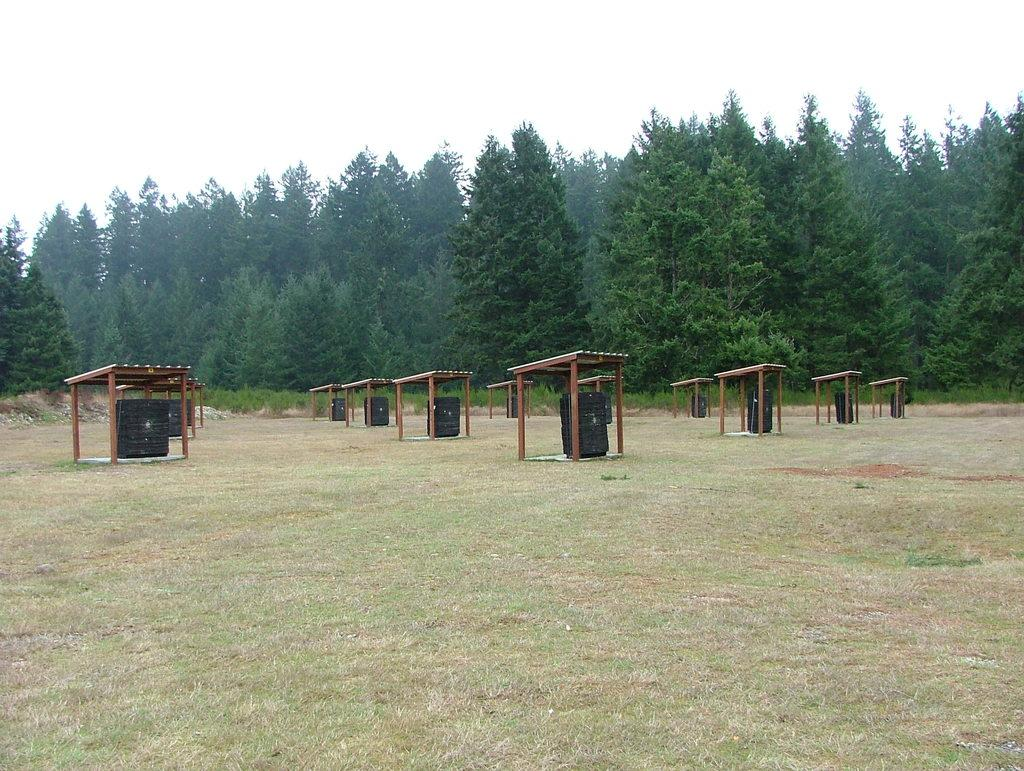What type of ground is visible in the image? There is a ground visible in the image. What structures are present on the ground? There are small sheds on the ground. What can be found inside the sheds? There are black color objects inside the sheds. What type of vegetation is present in the image? There are trees in the image. What is the condition of the sky in the image? The sky is clear in the image. Can you tell me how many cushions are placed on the ground in the image? There is no mention of cushions in the image, so we cannot determine their presence or quantity. 